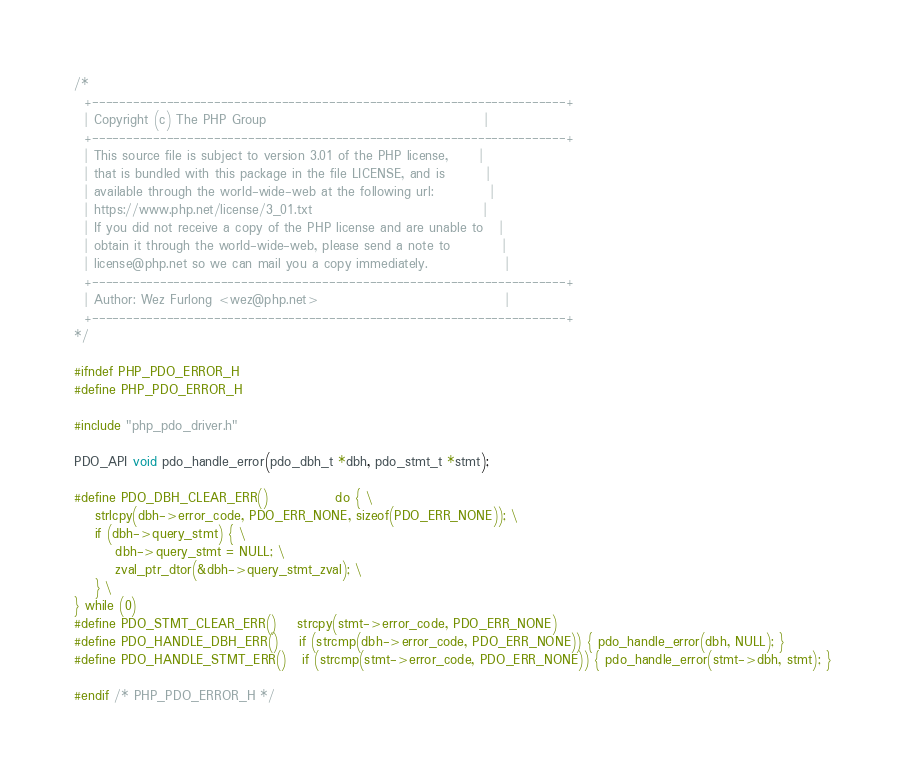Convert code to text. <code><loc_0><loc_0><loc_500><loc_500><_C_>/*
  +----------------------------------------------------------------------+
  | Copyright (c) The PHP Group                                          |
  +----------------------------------------------------------------------+
  | This source file is subject to version 3.01 of the PHP license,      |
  | that is bundled with this package in the file LICENSE, and is        |
  | available through the world-wide-web at the following url:           |
  | https://www.php.net/license/3_01.txt                                 |
  | If you did not receive a copy of the PHP license and are unable to   |
  | obtain it through the world-wide-web, please send a note to          |
  | license@php.net so we can mail you a copy immediately.               |
  +----------------------------------------------------------------------+
  | Author: Wez Furlong <wez@php.net>                                    |
  +----------------------------------------------------------------------+
*/

#ifndef PHP_PDO_ERROR_H
#define PHP_PDO_ERROR_H

#include "php_pdo_driver.h"

PDO_API void pdo_handle_error(pdo_dbh_t *dbh, pdo_stmt_t *stmt);

#define PDO_DBH_CLEAR_ERR()             do { \
	strlcpy(dbh->error_code, PDO_ERR_NONE, sizeof(PDO_ERR_NONE)); \
	if (dbh->query_stmt) { \
		dbh->query_stmt = NULL; \
		zval_ptr_dtor(&dbh->query_stmt_zval); \
	} \
} while (0)
#define PDO_STMT_CLEAR_ERR()    strcpy(stmt->error_code, PDO_ERR_NONE)
#define PDO_HANDLE_DBH_ERR()    if (strcmp(dbh->error_code, PDO_ERR_NONE)) { pdo_handle_error(dbh, NULL); }
#define PDO_HANDLE_STMT_ERR()   if (strcmp(stmt->error_code, PDO_ERR_NONE)) { pdo_handle_error(stmt->dbh, stmt); }

#endif /* PHP_PDO_ERROR_H */
</code> 